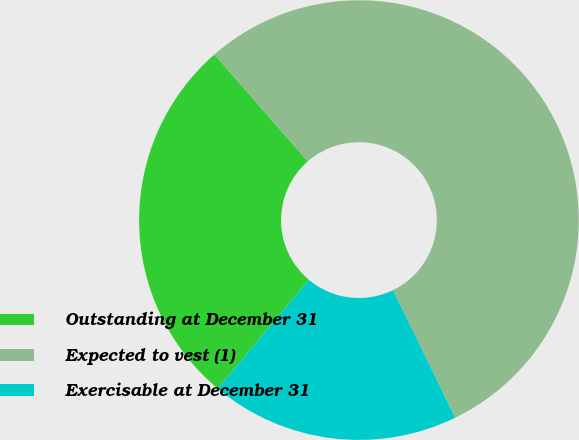Convert chart to OTSL. <chart><loc_0><loc_0><loc_500><loc_500><pie_chart><fcel>Outstanding at December 31<fcel>Expected to vest (1)<fcel>Exercisable at December 31<nl><fcel>27.48%<fcel>54.2%<fcel>18.32%<nl></chart> 